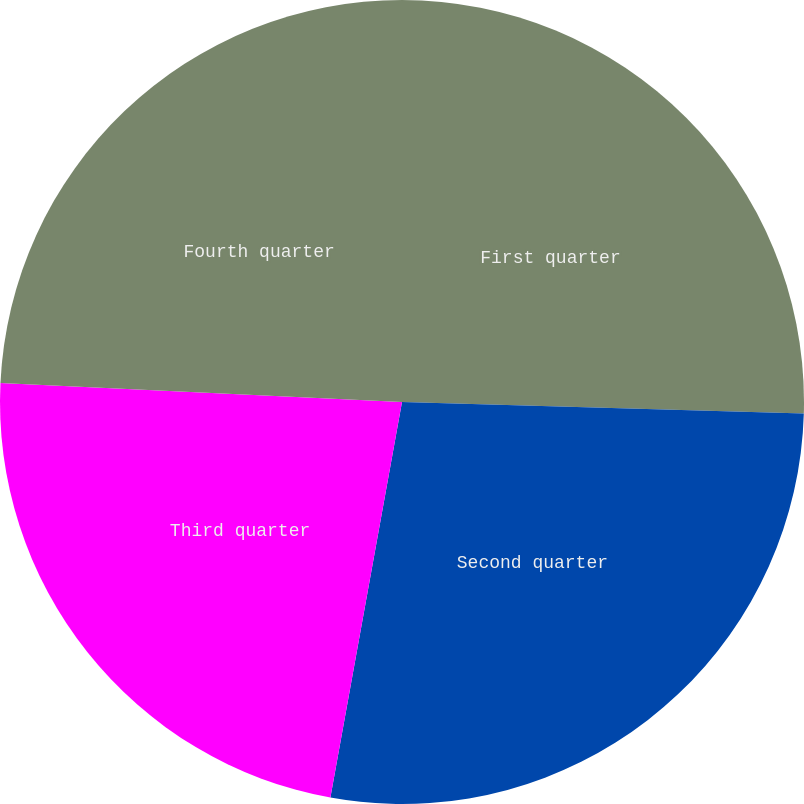Convert chart to OTSL. <chart><loc_0><loc_0><loc_500><loc_500><pie_chart><fcel>First quarter<fcel>Second quarter<fcel>Third quarter<fcel>Fourth quarter<nl><fcel>25.46%<fcel>27.39%<fcel>22.9%<fcel>24.25%<nl></chart> 